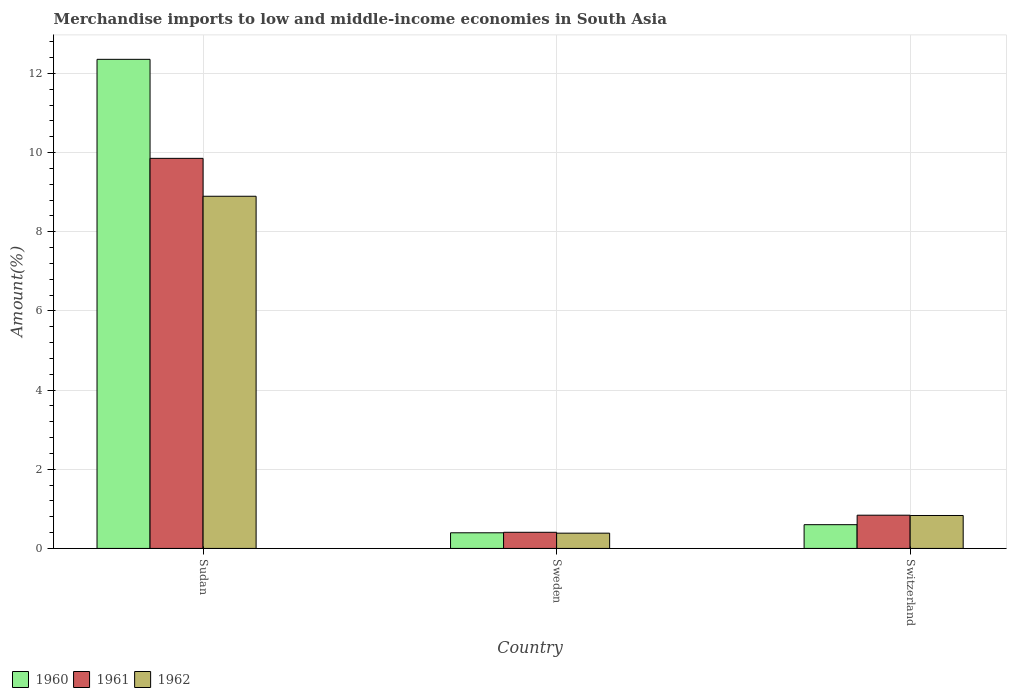How many different coloured bars are there?
Provide a short and direct response. 3. How many groups of bars are there?
Your answer should be compact. 3. What is the label of the 1st group of bars from the left?
Provide a succinct answer. Sudan. In how many cases, is the number of bars for a given country not equal to the number of legend labels?
Your answer should be very brief. 0. What is the percentage of amount earned from merchandise imports in 1960 in Switzerland?
Give a very brief answer. 0.6. Across all countries, what is the maximum percentage of amount earned from merchandise imports in 1960?
Keep it short and to the point. 12.35. Across all countries, what is the minimum percentage of amount earned from merchandise imports in 1961?
Your answer should be very brief. 0.41. In which country was the percentage of amount earned from merchandise imports in 1960 maximum?
Your answer should be compact. Sudan. What is the total percentage of amount earned from merchandise imports in 1961 in the graph?
Offer a terse response. 11.1. What is the difference between the percentage of amount earned from merchandise imports in 1960 in Sudan and that in Switzerland?
Make the answer very short. 11.75. What is the difference between the percentage of amount earned from merchandise imports in 1961 in Sweden and the percentage of amount earned from merchandise imports in 1960 in Sudan?
Offer a very short reply. -11.95. What is the average percentage of amount earned from merchandise imports in 1961 per country?
Offer a very short reply. 3.7. What is the difference between the percentage of amount earned from merchandise imports of/in 1961 and percentage of amount earned from merchandise imports of/in 1960 in Switzerland?
Your answer should be compact. 0.24. What is the ratio of the percentage of amount earned from merchandise imports in 1960 in Sudan to that in Sweden?
Make the answer very short. 31.28. Is the difference between the percentage of amount earned from merchandise imports in 1961 in Sweden and Switzerland greater than the difference between the percentage of amount earned from merchandise imports in 1960 in Sweden and Switzerland?
Keep it short and to the point. No. What is the difference between the highest and the second highest percentage of amount earned from merchandise imports in 1962?
Offer a terse response. 8.06. What is the difference between the highest and the lowest percentage of amount earned from merchandise imports in 1961?
Ensure brevity in your answer.  9.45. In how many countries, is the percentage of amount earned from merchandise imports in 1960 greater than the average percentage of amount earned from merchandise imports in 1960 taken over all countries?
Make the answer very short. 1. Is the sum of the percentage of amount earned from merchandise imports in 1962 in Sudan and Switzerland greater than the maximum percentage of amount earned from merchandise imports in 1961 across all countries?
Offer a very short reply. No. What does the 2nd bar from the right in Sweden represents?
Provide a succinct answer. 1961. Are all the bars in the graph horizontal?
Keep it short and to the point. No. Does the graph contain any zero values?
Give a very brief answer. No. Where does the legend appear in the graph?
Your answer should be very brief. Bottom left. How are the legend labels stacked?
Your answer should be compact. Horizontal. What is the title of the graph?
Make the answer very short. Merchandise imports to low and middle-income economies in South Asia. What is the label or title of the X-axis?
Your answer should be very brief. Country. What is the label or title of the Y-axis?
Give a very brief answer. Amount(%). What is the Amount(%) of 1960 in Sudan?
Give a very brief answer. 12.35. What is the Amount(%) in 1961 in Sudan?
Offer a very short reply. 9.85. What is the Amount(%) in 1962 in Sudan?
Offer a very short reply. 8.9. What is the Amount(%) of 1960 in Sweden?
Offer a terse response. 0.39. What is the Amount(%) of 1961 in Sweden?
Ensure brevity in your answer.  0.41. What is the Amount(%) in 1962 in Sweden?
Provide a succinct answer. 0.39. What is the Amount(%) of 1960 in Switzerland?
Keep it short and to the point. 0.6. What is the Amount(%) of 1961 in Switzerland?
Offer a very short reply. 0.84. What is the Amount(%) in 1962 in Switzerland?
Give a very brief answer. 0.83. Across all countries, what is the maximum Amount(%) in 1960?
Provide a short and direct response. 12.35. Across all countries, what is the maximum Amount(%) in 1961?
Offer a very short reply. 9.85. Across all countries, what is the maximum Amount(%) of 1962?
Ensure brevity in your answer.  8.9. Across all countries, what is the minimum Amount(%) in 1960?
Ensure brevity in your answer.  0.39. Across all countries, what is the minimum Amount(%) of 1961?
Make the answer very short. 0.41. Across all countries, what is the minimum Amount(%) in 1962?
Make the answer very short. 0.39. What is the total Amount(%) of 1960 in the graph?
Your answer should be very brief. 13.35. What is the total Amount(%) in 1961 in the graph?
Give a very brief answer. 11.1. What is the total Amount(%) in 1962 in the graph?
Make the answer very short. 10.11. What is the difference between the Amount(%) in 1960 in Sudan and that in Sweden?
Your response must be concise. 11.96. What is the difference between the Amount(%) in 1961 in Sudan and that in Sweden?
Provide a short and direct response. 9.45. What is the difference between the Amount(%) in 1962 in Sudan and that in Sweden?
Your response must be concise. 8.51. What is the difference between the Amount(%) in 1960 in Sudan and that in Switzerland?
Your response must be concise. 11.75. What is the difference between the Amount(%) in 1961 in Sudan and that in Switzerland?
Make the answer very short. 9.01. What is the difference between the Amount(%) of 1962 in Sudan and that in Switzerland?
Offer a terse response. 8.06. What is the difference between the Amount(%) of 1960 in Sweden and that in Switzerland?
Offer a terse response. -0.2. What is the difference between the Amount(%) in 1961 in Sweden and that in Switzerland?
Make the answer very short. -0.43. What is the difference between the Amount(%) in 1962 in Sweden and that in Switzerland?
Ensure brevity in your answer.  -0.45. What is the difference between the Amount(%) of 1960 in Sudan and the Amount(%) of 1961 in Sweden?
Provide a succinct answer. 11.95. What is the difference between the Amount(%) in 1960 in Sudan and the Amount(%) in 1962 in Sweden?
Make the answer very short. 11.97. What is the difference between the Amount(%) of 1961 in Sudan and the Amount(%) of 1962 in Sweden?
Ensure brevity in your answer.  9.47. What is the difference between the Amount(%) in 1960 in Sudan and the Amount(%) in 1961 in Switzerland?
Your answer should be compact. 11.51. What is the difference between the Amount(%) of 1960 in Sudan and the Amount(%) of 1962 in Switzerland?
Give a very brief answer. 11.52. What is the difference between the Amount(%) of 1961 in Sudan and the Amount(%) of 1962 in Switzerland?
Provide a succinct answer. 9.02. What is the difference between the Amount(%) of 1960 in Sweden and the Amount(%) of 1961 in Switzerland?
Your answer should be very brief. -0.44. What is the difference between the Amount(%) of 1960 in Sweden and the Amount(%) of 1962 in Switzerland?
Give a very brief answer. -0.44. What is the difference between the Amount(%) of 1961 in Sweden and the Amount(%) of 1962 in Switzerland?
Provide a short and direct response. -0.42. What is the average Amount(%) in 1960 per country?
Keep it short and to the point. 4.45. What is the average Amount(%) of 1961 per country?
Give a very brief answer. 3.7. What is the average Amount(%) of 1962 per country?
Your answer should be compact. 3.37. What is the difference between the Amount(%) of 1960 and Amount(%) of 1961 in Sudan?
Make the answer very short. 2.5. What is the difference between the Amount(%) in 1960 and Amount(%) in 1962 in Sudan?
Your answer should be very brief. 3.46. What is the difference between the Amount(%) in 1961 and Amount(%) in 1962 in Sudan?
Provide a short and direct response. 0.96. What is the difference between the Amount(%) of 1960 and Amount(%) of 1961 in Sweden?
Provide a succinct answer. -0.01. What is the difference between the Amount(%) in 1960 and Amount(%) in 1962 in Sweden?
Give a very brief answer. 0.01. What is the difference between the Amount(%) in 1961 and Amount(%) in 1962 in Sweden?
Provide a short and direct response. 0.02. What is the difference between the Amount(%) of 1960 and Amount(%) of 1961 in Switzerland?
Provide a succinct answer. -0.24. What is the difference between the Amount(%) of 1960 and Amount(%) of 1962 in Switzerland?
Keep it short and to the point. -0.23. What is the difference between the Amount(%) of 1961 and Amount(%) of 1962 in Switzerland?
Your answer should be very brief. 0.01. What is the ratio of the Amount(%) of 1960 in Sudan to that in Sweden?
Provide a short and direct response. 31.28. What is the ratio of the Amount(%) in 1961 in Sudan to that in Sweden?
Your response must be concise. 24.17. What is the ratio of the Amount(%) of 1962 in Sudan to that in Sweden?
Offer a terse response. 23.06. What is the ratio of the Amount(%) in 1960 in Sudan to that in Switzerland?
Provide a succinct answer. 20.59. What is the ratio of the Amount(%) in 1961 in Sudan to that in Switzerland?
Give a very brief answer. 11.73. What is the ratio of the Amount(%) in 1962 in Sudan to that in Switzerland?
Provide a short and direct response. 10.69. What is the ratio of the Amount(%) of 1960 in Sweden to that in Switzerland?
Provide a short and direct response. 0.66. What is the ratio of the Amount(%) of 1961 in Sweden to that in Switzerland?
Your answer should be compact. 0.49. What is the ratio of the Amount(%) of 1962 in Sweden to that in Switzerland?
Offer a very short reply. 0.46. What is the difference between the highest and the second highest Amount(%) in 1960?
Offer a very short reply. 11.75. What is the difference between the highest and the second highest Amount(%) of 1961?
Your answer should be very brief. 9.01. What is the difference between the highest and the second highest Amount(%) of 1962?
Provide a short and direct response. 8.06. What is the difference between the highest and the lowest Amount(%) in 1960?
Your answer should be compact. 11.96. What is the difference between the highest and the lowest Amount(%) of 1961?
Keep it short and to the point. 9.45. What is the difference between the highest and the lowest Amount(%) in 1962?
Give a very brief answer. 8.51. 